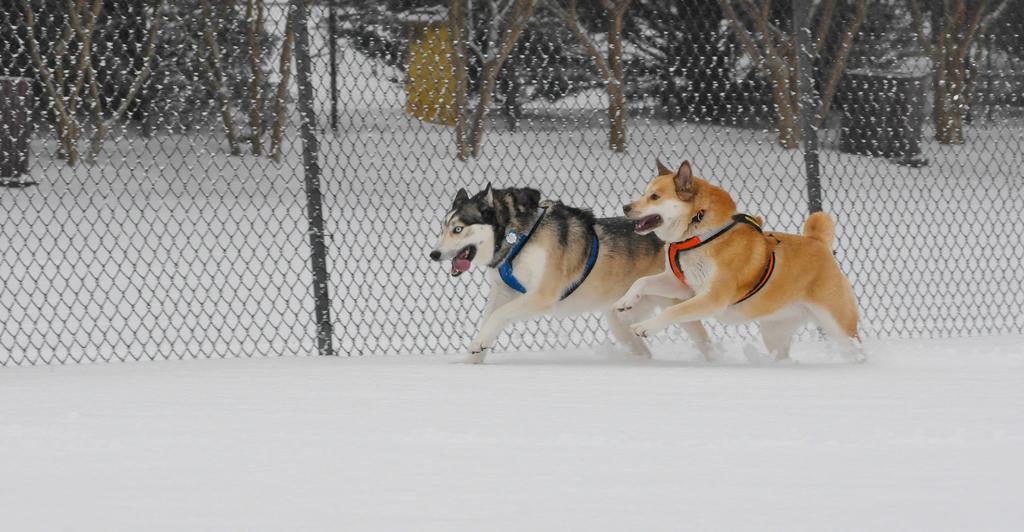In one or two sentences, can you explain what this image depicts? In this image, we can see husky and dog are running on the snow. In the background, we can see mesh, poles, trees and few objects. 